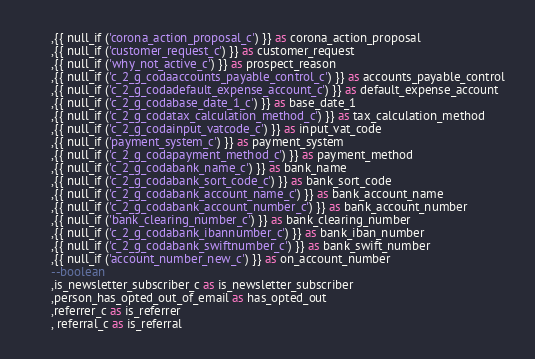Convert code to text. <code><loc_0><loc_0><loc_500><loc_500><_SQL_>      ,{{ null_if ('corona_action_proposal_c') }} as corona_action_proposal
      ,{{ null_if ('customer_request_c') }} as customer_request
      ,{{ null_if ('why_not_active_c') }} as prospect_reason
      ,{{ null_if ('c_2_g_codaaccounts_payable_control_c') }} as accounts_payable_control
      ,{{ null_if ('c_2_g_codadefault_expense_account_c') }} as default_expense_account
      ,{{ null_if ('c_2_g_codabase_date_1_c') }} as base_date_1
      ,{{ null_if ('c_2_g_codatax_calculation_method_c') }} as tax_calculation_method
      ,{{ null_if ('c_2_g_codainput_vatcode_c') }} as input_vat_code
      ,{{ null_if ('payment_system_c') }} as payment_system
      ,{{ null_if ('c_2_g_codapayment_method_c') }} as payment_method
      ,{{ null_if ('c_2_g_codabank_name_c') }} as bank_name
      ,{{ null_if ('c_2_g_codabank_sort_code_c') }} as bank_sort_code
      ,{{ null_if ('c_2_g_codabank_account_name_c') }} as bank_account_name
      ,{{ null_if ('c_2_g_codabank_account_number_c') }} as bank_account_number
      ,{{ null_if ('bank_clearing_number_c') }} as bank_clearing_number
      ,{{ null_if ('c_2_g_codabank_ibannumber_c') }} as bank_iban_number
      ,{{ null_if ('c_2_g_codabank_swiftnumber_c') }} as bank_swift_number
      ,{{ null_if ('account_number_new_c') }} as on_account_number
      --boolean
      ,is_newsletter_subscriber_c as is_newsletter_subscriber
      ,person_has_opted_out_of_email as has_opted_out
      ,referrer_c as is_referrer
      , referral_c as is_referral</code> 